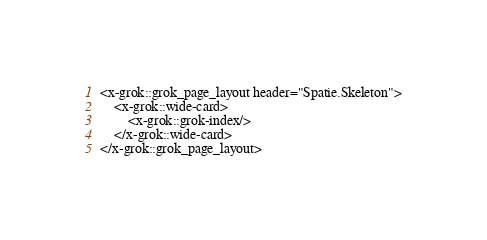<code> <loc_0><loc_0><loc_500><loc_500><_PHP_><x-grok::grok_page_layout header="Spatie.Skeleton">
    <x-grok::wide-card>
        <x-grok::grok-index/>
    </x-grok::wide-card>
</x-grok::grok_page_layout>

</code> 